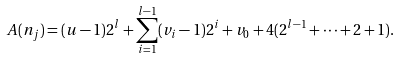Convert formula to latex. <formula><loc_0><loc_0><loc_500><loc_500>A ( n _ { j } ) = ( u - 1 ) 2 ^ { l } + \sum _ { i = 1 } ^ { l - 1 } ( v _ { i } - 1 ) 2 ^ { i } + v _ { 0 } + 4 ( 2 ^ { l - 1 } + \cdots + 2 + 1 ) .</formula> 